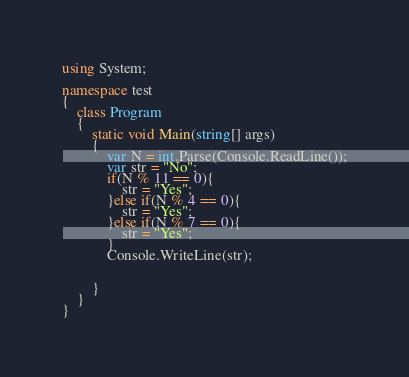<code> <loc_0><loc_0><loc_500><loc_500><_C#_>using System;

namespace test
{
    class Program
    {
        static void Main(string[] args)
        {
            var N = int.Parse(Console.ReadLine());
            var str = "No";
            if(N % 11 == 0){
                str = "Yes";
            }else if(N % 4 == 0){
                str = "Yes";
            }else if(N % 7 == 0){
                str = "Yes";
            }
            Console.WriteLine(str);


        }
    }
}
</code> 